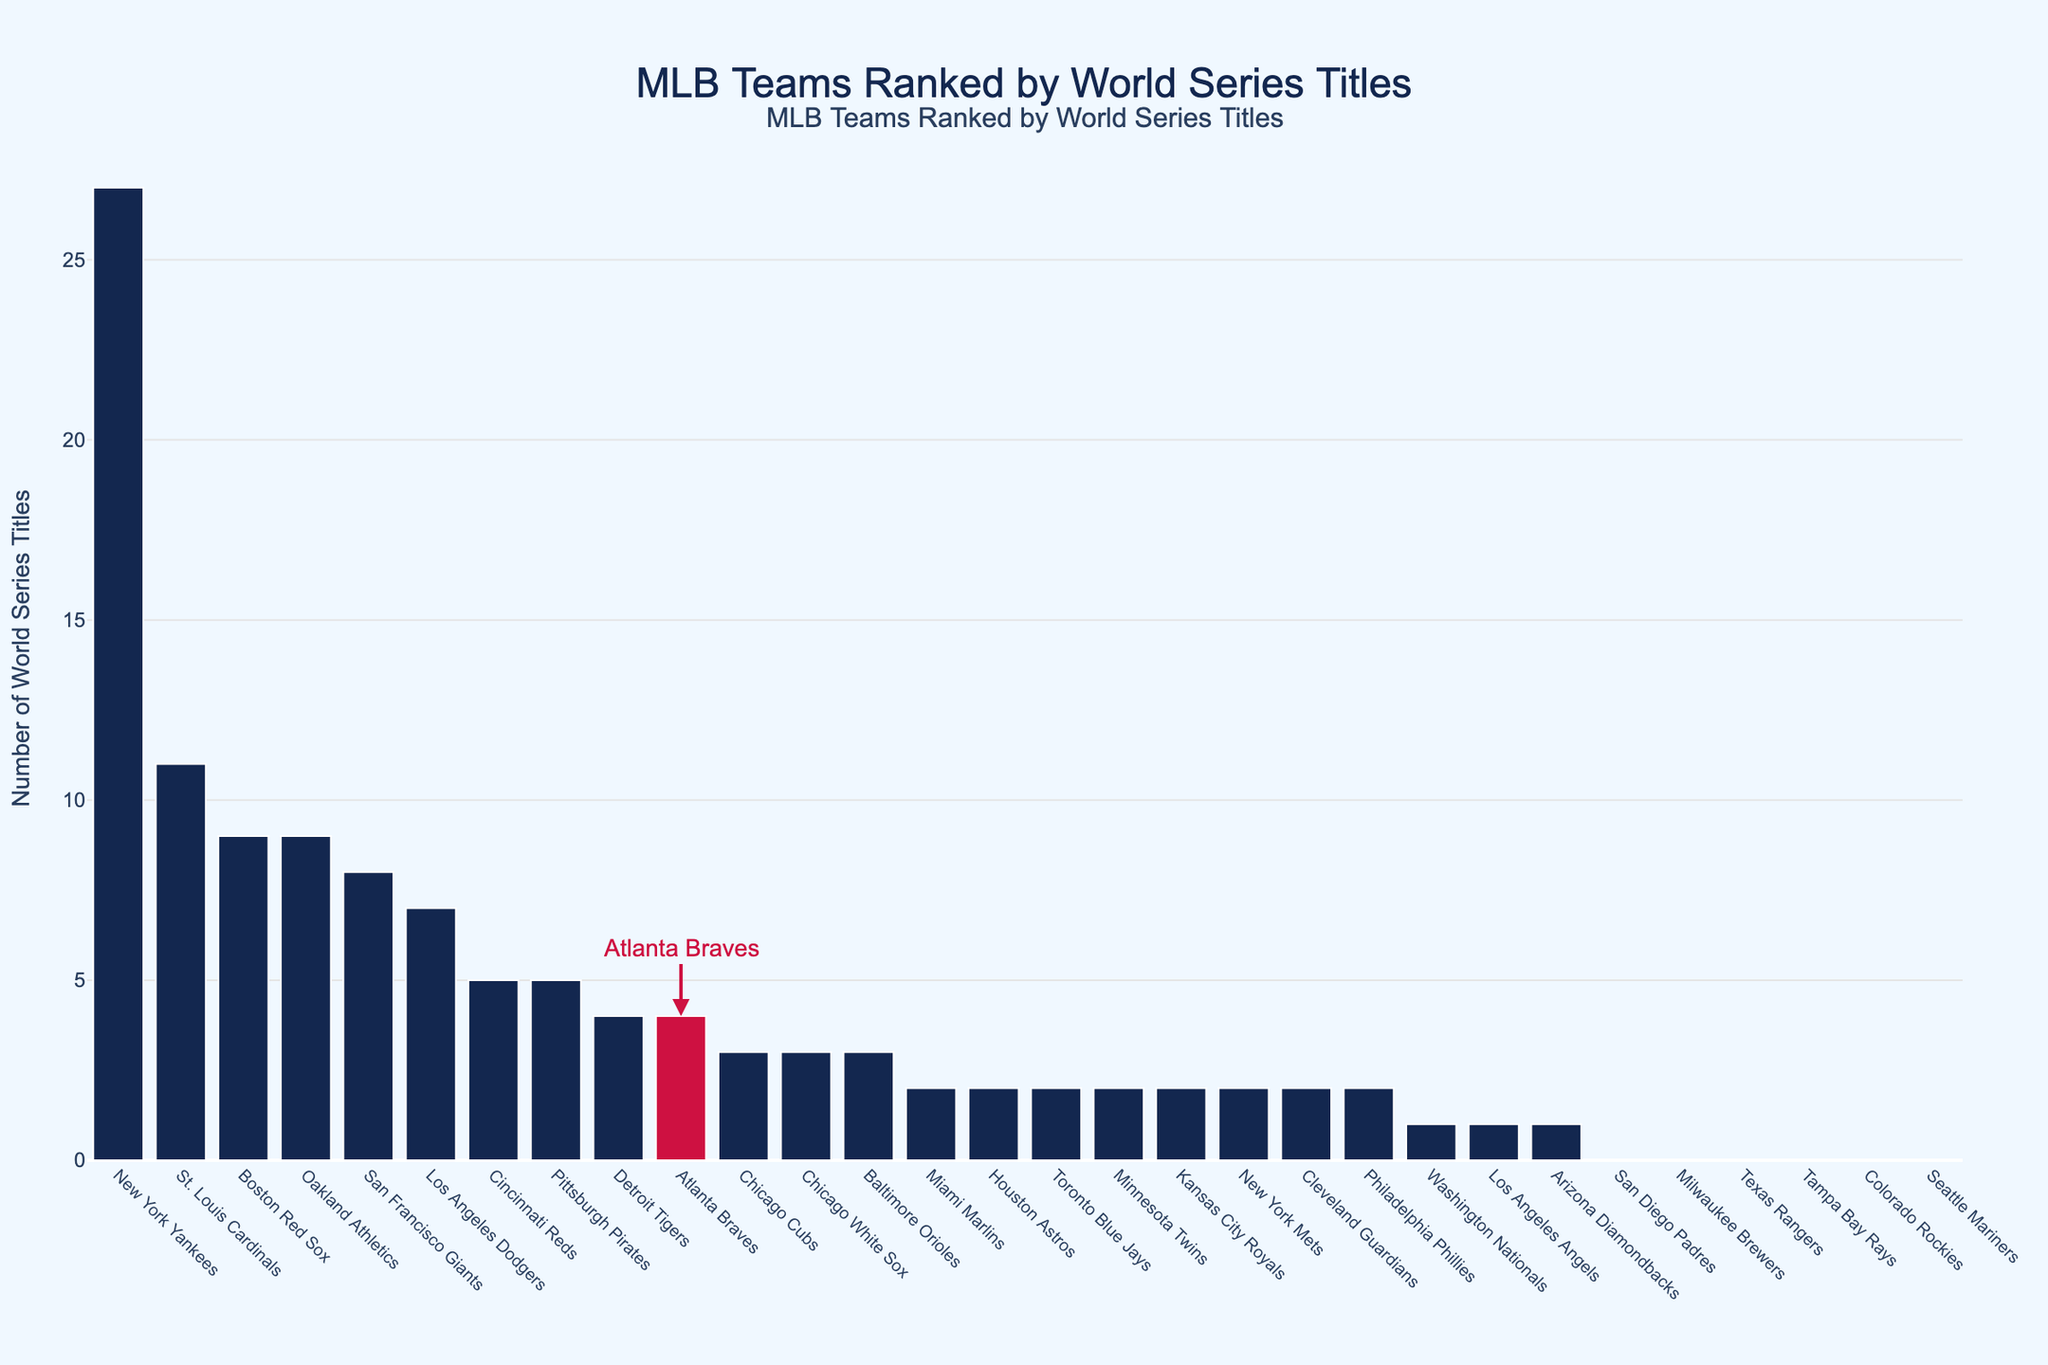Which team has won the most World Series titles? The tallest bar represents the team with the most titles. The New York Yankees have the tallest bar with 27 titles.
Answer: New York Yankees How many more titles do the New York Yankees have compared to the St. Louis Cardinals? The New York Yankees have 27 titles and the St. Louis Cardinals have 11. The difference is 27 - 11 = 16 titles.
Answer: 16 By how many titles does the Boston Red Sox surpass the Atlanta Braves? The Boston Red Sox have 9 titles and the Atlanta Braves have 4. The difference is 9 - 4 = 5 titles.
Answer: 5 Which teams have never won a World Series title? Bars with the height of zero represent teams with no titles. The teams include: San Diego Padres, Milwaukee Brewers, Texas Rangers, Tampa Bay Rays, Colorado Rockies, and Seattle Mariners.
Answer: San Diego Padres, Milwaukee Brewers, Texas Rangers, Tampa Bay Rays, Colorado Rockies, Seattle Mariners What is the combined total of World Series titles for the teams with exactly 2 titles each? The teams with exactly 2 titles are Philadelphia Phillies, Cleveland Guardians, New York Mets, Minnesota Twins, Kansas City Royals, Miami Marlins, Toronto Blue Jays, and Houston Astros. Summing their titles: 2 + 2 + 2 + 2 + 2 + 2 + 2 + 2 = 16.
Answer: 16 Are there more teams with exactly 3 titles or exactly 2 titles? By counting the bars, we see 3 titles: Chicago Cubs, Chicago White Sox, Baltimore Orioles (3 teams); 2 titles: Philadelphia Phillies, Cleveland Guardians, New York Mets, Minnesota Twins, Kansas City Royals, Miami Marlins, Toronto Blue Jays, Houston Astros (8 teams). There are more teams with exactly 2 titles.
Answer: 2 titles Which team is highlighted in red on the chart and how many titles do they have? The highlighted red bar represents the Atlanta Braves, which is labelled and indicated by the arrow on the chart. The number of titles they have is 4.
Answer: Atlanta Braves, 4 Out of the teams that have won at least 5 titles, which team has the second lowest number of titles? The teams with at least 5 titles are New York Yankees (27), St. Louis Cardinals (11), Boston Red Sox (9), Oakland Athletics (9), San Francisco Giants (8), Los Angeles Dodgers (7), Cincinnati Reds (5), Pittsburgh Pirates (5). Among these, Cincinnati Reds and Pittsburgh Pirates both have the second lowest number with 5 titles each.
Answer: Cincinnati Reds, Pittsburgh Pirates What is the average number of World Series titles for the Los Angeles Dodgers, Atlanta Braves, and Chicago Cubs combined? The Los Angeles Dodgers have 7 titles, the Atlanta Braves have 4, and the Chicago Cubs have 3. The total is 7 + 4 + 3 = 14. The average is 14 / 3 = 4.67 titles.
Answer: 4.67 Which team has won fewer titles: the Baltimore Orioles or the Cleveland Guardians? The Baltimore Orioles have 3 titles, while the Cleveland Guardians have 2 titles. Therefore, the Cleveland Guardians have won fewer titles.
Answer: Cleveland Guardians 